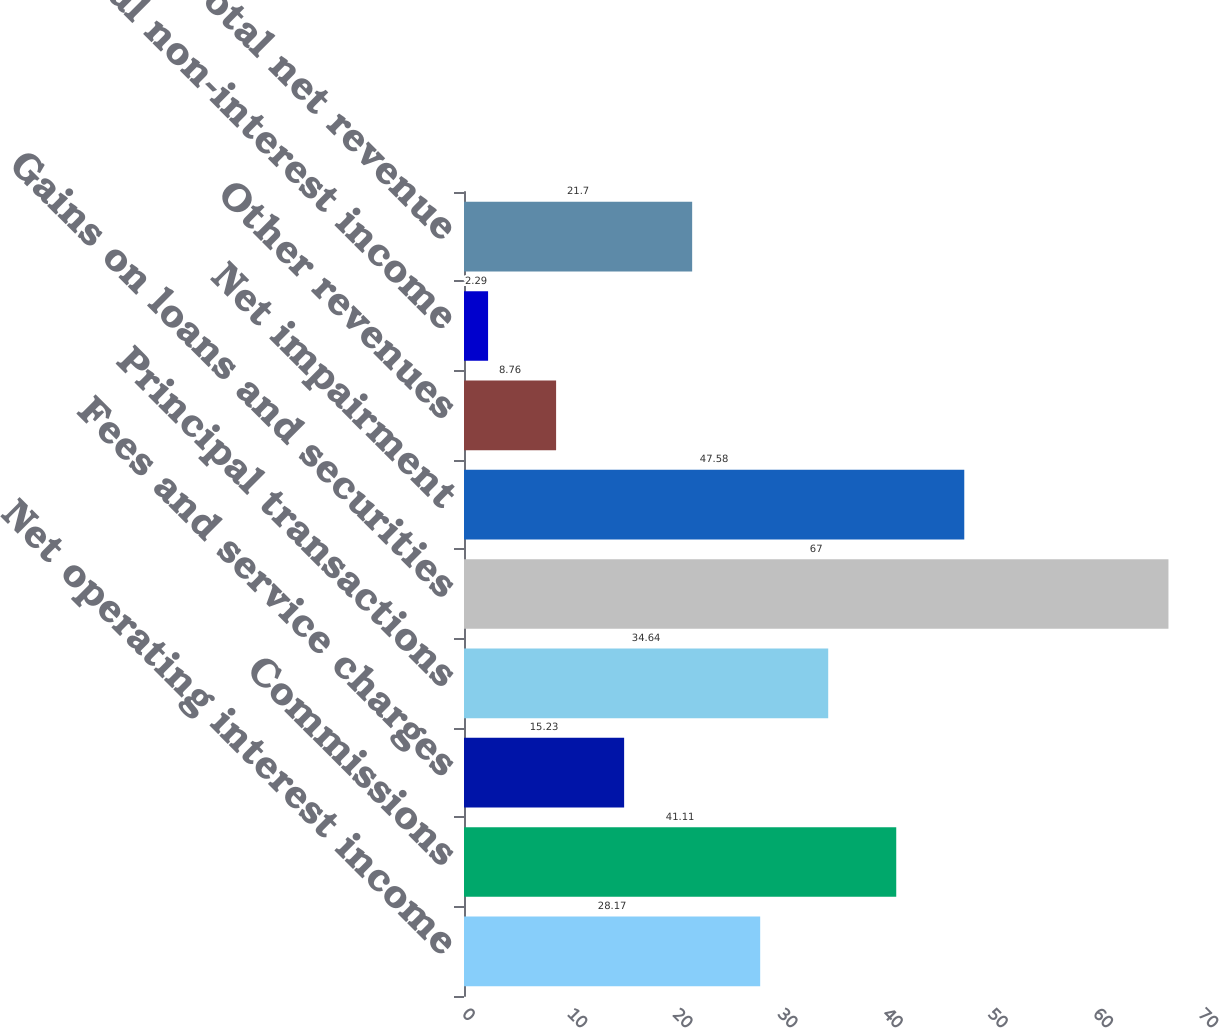Convert chart to OTSL. <chart><loc_0><loc_0><loc_500><loc_500><bar_chart><fcel>Net operating interest income<fcel>Commissions<fcel>Fees and service charges<fcel>Principal transactions<fcel>Gains on loans and securities<fcel>Net impairment<fcel>Other revenues<fcel>Total non-interest income<fcel>Total net revenue<nl><fcel>28.17<fcel>41.11<fcel>15.23<fcel>34.64<fcel>67<fcel>47.58<fcel>8.76<fcel>2.29<fcel>21.7<nl></chart> 